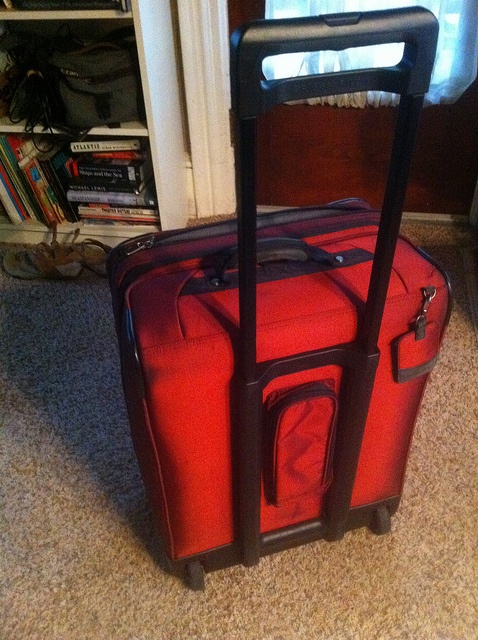Describe the objects in this image and their specific colors. I can see suitcase in black, red, maroon, and brown tones, book in black and gray tones, book in black, maroon, and gray tones, book in black, gray, maroon, and brown tones, and book in black and gray tones in this image. 